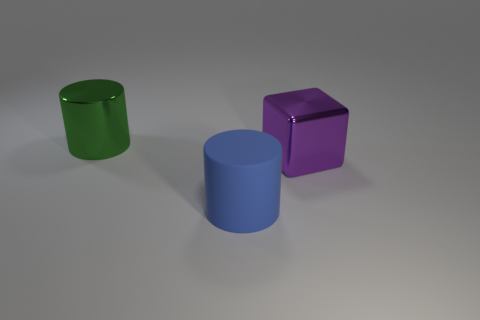Is the material of the big green cylinder the same as the blue thing?
Give a very brief answer. No. What number of metallic objects are large purple things or big green cylinders?
Provide a short and direct response. 2. There is a metal block that is the same size as the blue matte object; what color is it?
Provide a succinct answer. Purple. What number of large purple shiny things are the same shape as the matte object?
Your answer should be very brief. 0. How many balls are either large purple shiny things or big blue rubber things?
Your answer should be compact. 0. Does the large object that is to the left of the blue rubber cylinder have the same shape as the thing that is on the right side of the matte thing?
Offer a terse response. No. What is the material of the blue cylinder?
Offer a very short reply. Rubber. What number of blue metallic cubes are the same size as the purple thing?
Your response must be concise. 0. What number of things are metallic things on the left side of the big purple metal block or large cylinders in front of the big shiny block?
Provide a short and direct response. 2. Do the large cylinder that is behind the purple thing and the cylinder in front of the cube have the same material?
Provide a short and direct response. No. 